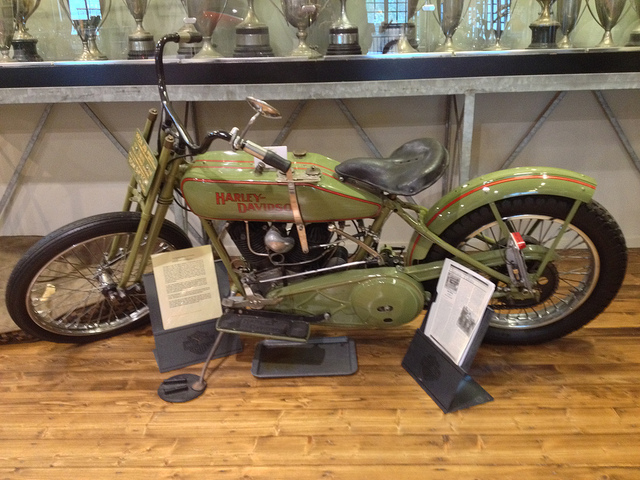<image>Which year was this motorcycle introduced for sale? It is unknown which year this motorcycle was introduced for sale. Which year was this motorcycle introduced for sale? It is unanswerable which year this motorcycle was introduced for sale. 